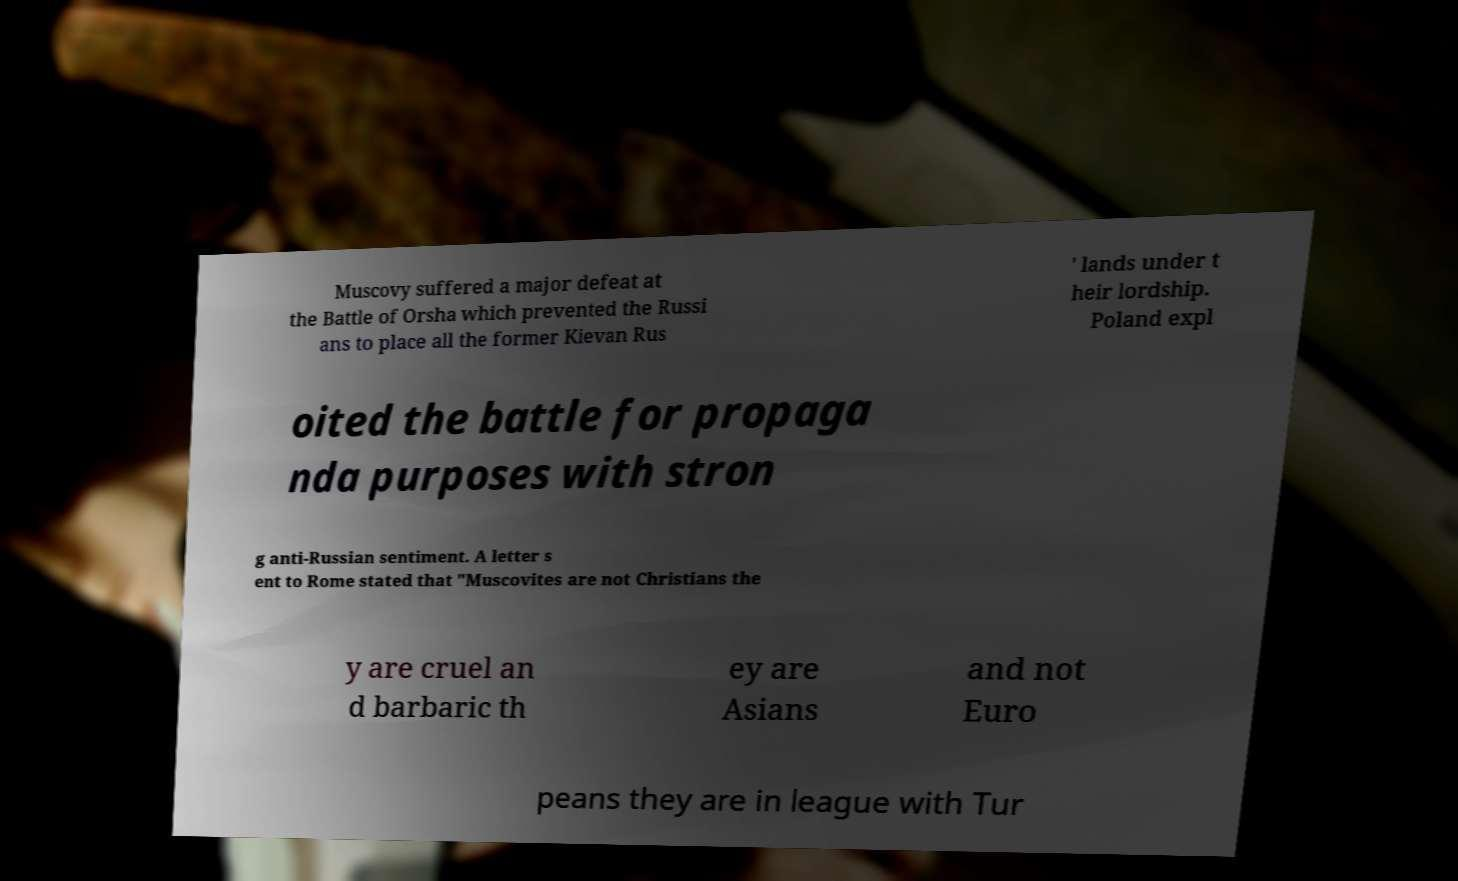Could you assist in decoding the text presented in this image and type it out clearly? Muscovy suffered a major defeat at the Battle of Orsha which prevented the Russi ans to place all the former Kievan Rus ' lands under t heir lordship. Poland expl oited the battle for propaga nda purposes with stron g anti-Russian sentiment. A letter s ent to Rome stated that "Muscovites are not Christians the y are cruel an d barbaric th ey are Asians and not Euro peans they are in league with Tur 